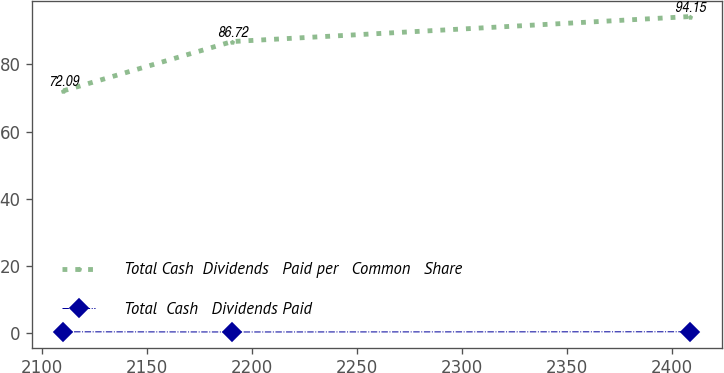<chart> <loc_0><loc_0><loc_500><loc_500><line_chart><ecel><fcel>Total Cash  Dividends   Paid per   Common   Share<fcel>Total  Cash   Dividends Paid<nl><fcel>2110.41<fcel>72.09<fcel>0.5<nl><fcel>2190.67<fcel>86.72<fcel>0.45<nl><fcel>2408.65<fcel>94.15<fcel>0.51<nl></chart> 